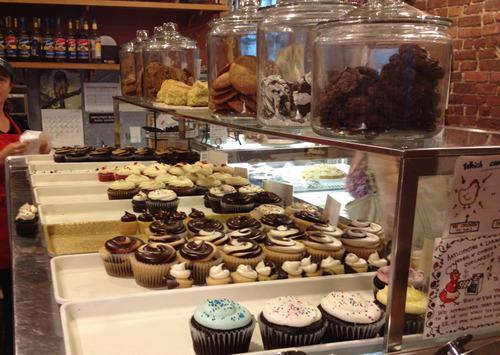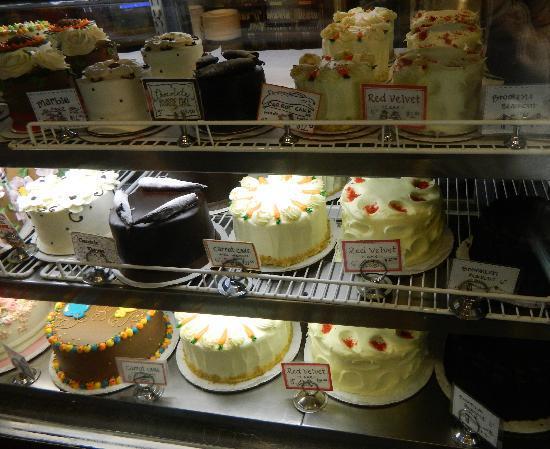The first image is the image on the left, the second image is the image on the right. Assess this claim about the two images: "Three rows of iced cakes are arranged in a bakery on a bottom metal rack and two upper white wire racks, with larger round cakes on the two lower racks.". Correct or not? Answer yes or no. Yes. The first image is the image on the left, the second image is the image on the right. Analyze the images presented: Is the assertion "A row of clear lidded canisters holding baked treats is on a chrome-edged shelf in a bakery." valid? Answer yes or no. Yes. 